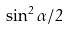Convert formula to latex. <formula><loc_0><loc_0><loc_500><loc_500>\sin ^ { 2 } \alpha / 2</formula> 